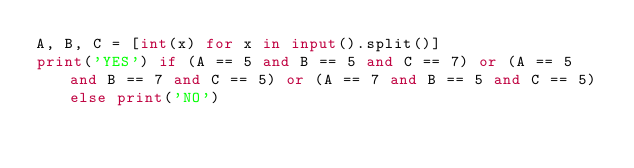Convert code to text. <code><loc_0><loc_0><loc_500><loc_500><_Python_>A, B, C = [int(x) for x in input().split()]
print('YES') if (A == 5 and B == 5 and C == 7) or (A == 5 and B == 7 and C == 5) or (A == 7 and B == 5 and C == 5) else print('NO') </code> 